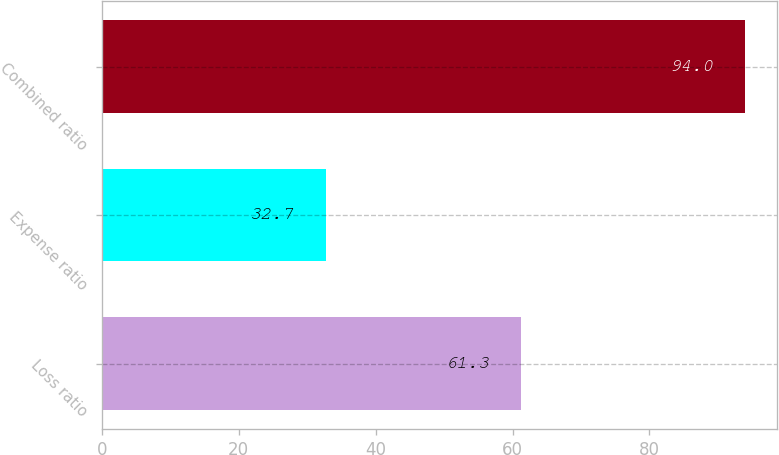Convert chart to OTSL. <chart><loc_0><loc_0><loc_500><loc_500><bar_chart><fcel>Loss ratio<fcel>Expense ratio<fcel>Combined ratio<nl><fcel>61.3<fcel>32.7<fcel>94<nl></chart> 